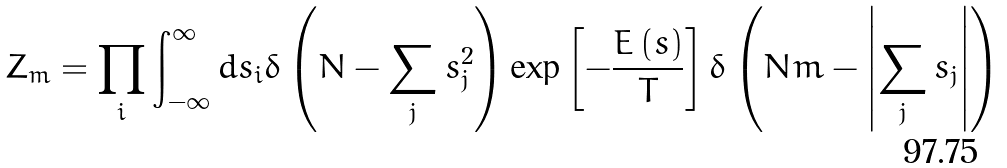Convert formula to latex. <formula><loc_0><loc_0><loc_500><loc_500>Z _ { m } = \prod _ { i } \int _ { - \infty } ^ { \infty } d s _ { i } \delta \left ( N - \sum _ { j } s _ { j } ^ { 2 } \right ) \exp \left [ - \frac { E \left ( { s } \right ) } { T } \right ] \delta \left ( N m - \left | \sum _ { j } s _ { j } \right | \right )</formula> 